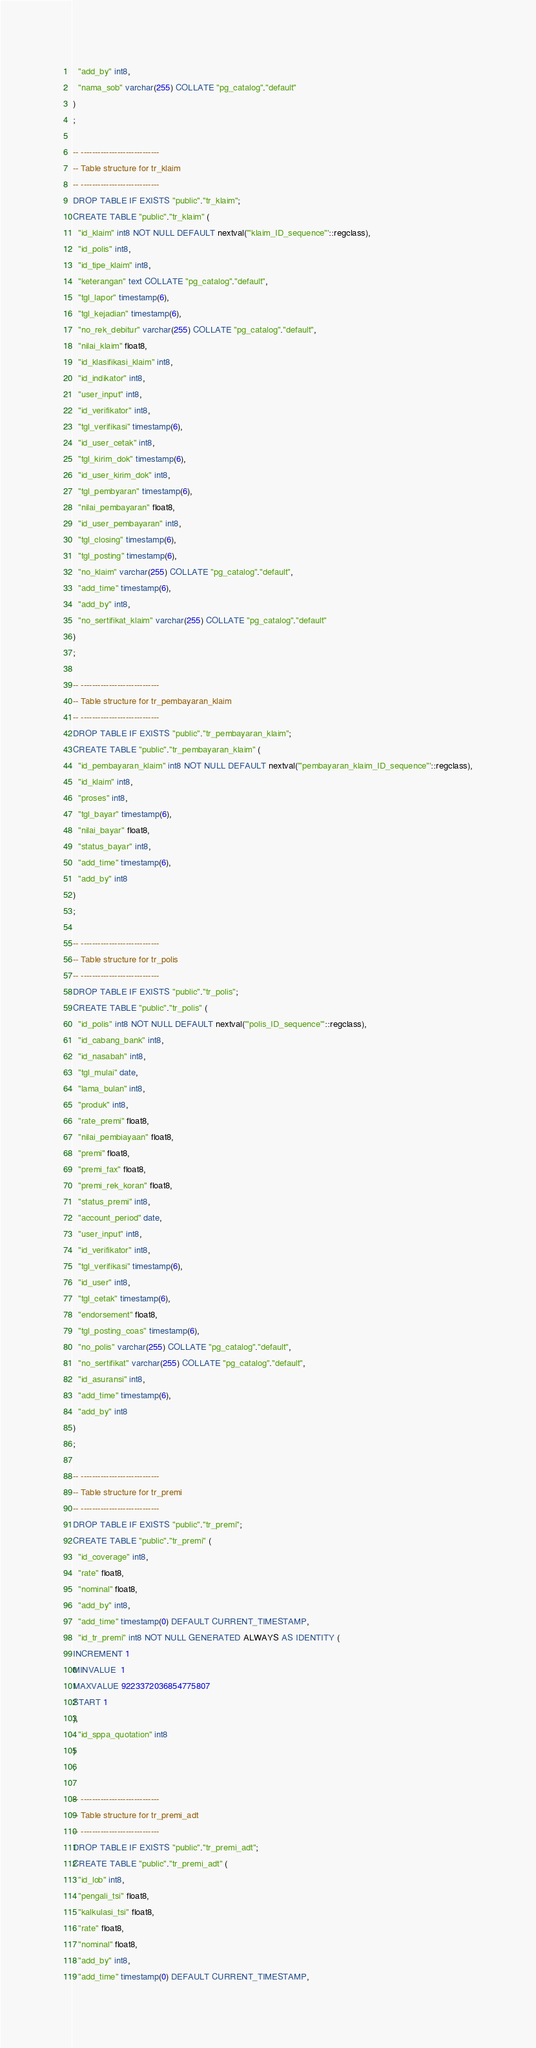Convert code to text. <code><loc_0><loc_0><loc_500><loc_500><_SQL_>  "add_by" int8,
  "nama_sob" varchar(255) COLLATE "pg_catalog"."default"
)
;

-- ----------------------------
-- Table structure for tr_klaim
-- ----------------------------
DROP TABLE IF EXISTS "public"."tr_klaim";
CREATE TABLE "public"."tr_klaim" (
  "id_klaim" int8 NOT NULL DEFAULT nextval('"klaim_ID_sequence"'::regclass),
  "id_polis" int8,
  "id_tipe_klaim" int8,
  "keterangan" text COLLATE "pg_catalog"."default",
  "tgl_lapor" timestamp(6),
  "tgl_kejadian" timestamp(6),
  "no_rek_debitur" varchar(255) COLLATE "pg_catalog"."default",
  "nilai_klaim" float8,
  "id_klasifikasi_klaim" int8,
  "id_indikator" int8,
  "user_input" int8,
  "id_verifikator" int8,
  "tgl_verifikasi" timestamp(6),
  "id_user_cetak" int8,
  "tgl_kirim_dok" timestamp(6),
  "id_user_kirim_dok" int8,
  "tgl_pembyaran" timestamp(6),
  "nilai_pembayaran" float8,
  "id_user_pembayaran" int8,
  "tgl_closing" timestamp(6),
  "tgl_posting" timestamp(6),
  "no_klaim" varchar(255) COLLATE "pg_catalog"."default",
  "add_time" timestamp(6),
  "add_by" int8,
  "no_sertifikat_klaim" varchar(255) COLLATE "pg_catalog"."default"
)
;

-- ----------------------------
-- Table structure for tr_pembayaran_klaim
-- ----------------------------
DROP TABLE IF EXISTS "public"."tr_pembayaran_klaim";
CREATE TABLE "public"."tr_pembayaran_klaim" (
  "id_pembayaran_klaim" int8 NOT NULL DEFAULT nextval('"pembayaran_klaim_ID_sequence"'::regclass),
  "id_klaim" int8,
  "proses" int8,
  "tgl_bayar" timestamp(6),
  "nilai_bayar" float8,
  "status_bayar" int8,
  "add_time" timestamp(6),
  "add_by" int8
)
;

-- ----------------------------
-- Table structure for tr_polis
-- ----------------------------
DROP TABLE IF EXISTS "public"."tr_polis";
CREATE TABLE "public"."tr_polis" (
  "id_polis" int8 NOT NULL DEFAULT nextval('"polis_ID_sequence"'::regclass),
  "id_cabang_bank" int8,
  "id_nasabah" int8,
  "tgl_mulai" date,
  "lama_bulan" int8,
  "produk" int8,
  "rate_premi" float8,
  "nilai_pembiayaan" float8,
  "premi" float8,
  "premi_fax" float8,
  "premi_rek_koran" float8,
  "status_premi" int8,
  "account_period" date,
  "user_input" int8,
  "id_verifikator" int8,
  "tgl_verifikasi" timestamp(6),
  "id_user" int8,
  "tgl_cetak" timestamp(6),
  "endorsement" float8,
  "tgl_posting_coas" timestamp(6),
  "no_polis" varchar(255) COLLATE "pg_catalog"."default",
  "no_sertifikat" varchar(255) COLLATE "pg_catalog"."default",
  "id_asuransi" int8,
  "add_time" timestamp(6),
  "add_by" int8
)
;

-- ----------------------------
-- Table structure for tr_premi
-- ----------------------------
DROP TABLE IF EXISTS "public"."tr_premi";
CREATE TABLE "public"."tr_premi" (
  "id_coverage" int8,
  "rate" float8,
  "nominal" float8,
  "add_by" int8,
  "add_time" timestamp(0) DEFAULT CURRENT_TIMESTAMP,
  "id_tr_premi" int8 NOT NULL GENERATED ALWAYS AS IDENTITY (
INCREMENT 1
MINVALUE  1
MAXVALUE 9223372036854775807
START 1
),
  "id_sppa_quotation" int8
)
;

-- ----------------------------
-- Table structure for tr_premi_adt
-- ----------------------------
DROP TABLE IF EXISTS "public"."tr_premi_adt";
CREATE TABLE "public"."tr_premi_adt" (
  "id_lob" int8,
  "pengali_tsi" float8,
  "kalkulasi_tsi" float8,
  "rate" float8,
  "nominal" float8,
  "add_by" int8,
  "add_time" timestamp(0) DEFAULT CURRENT_TIMESTAMP,</code> 